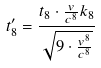<formula> <loc_0><loc_0><loc_500><loc_500>t _ { 8 } ^ { \prime } = \frac { t _ { 8 } \cdot \frac { v } { c ^ { 8 } } k _ { 8 } } { \sqrt { 9 \cdot \frac { v ^ { 8 } } { c ^ { 8 } } } }</formula> 